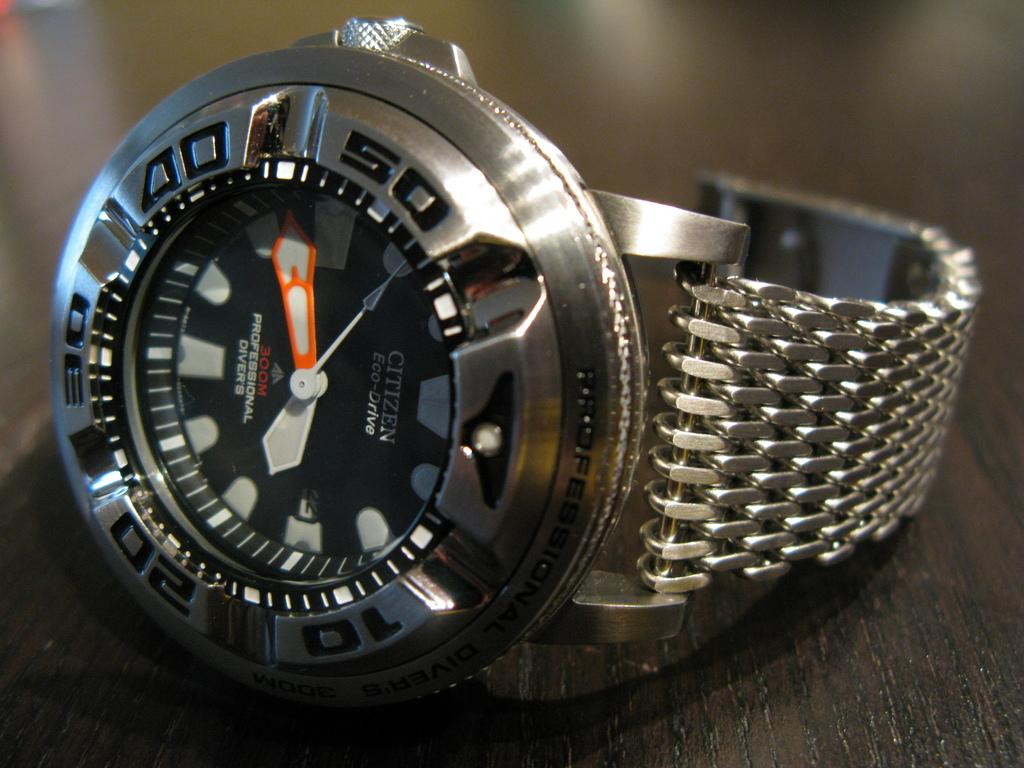<image>
Render a clear and concise summary of the photo. The Citizen Eco-Drive wrist watch says that the time is about 17 minutes before 4 o'clock. 